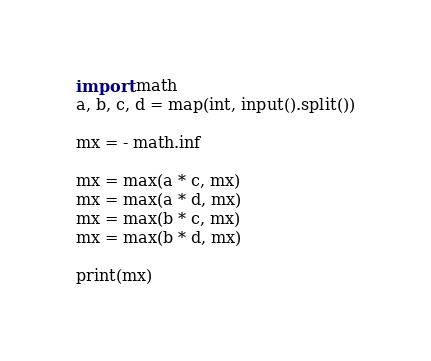<code> <loc_0><loc_0><loc_500><loc_500><_Python_>import math
a, b, c, d = map(int, input().split())

mx = - math.inf

mx = max(a * c, mx)
mx = max(a * d, mx)
mx = max(b * c, mx)
mx = max(b * d, mx)

print(mx)
</code> 